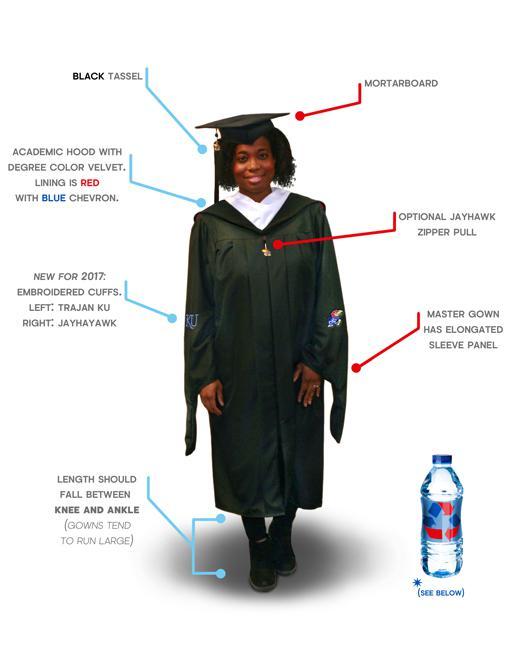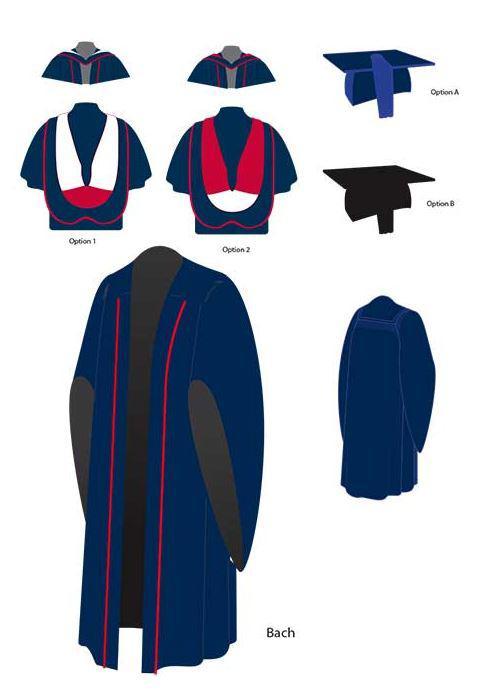The first image is the image on the left, the second image is the image on the right. Evaluate the accuracy of this statement regarding the images: "There is a women in one of the images.". Is it true? Answer yes or no. Yes. 